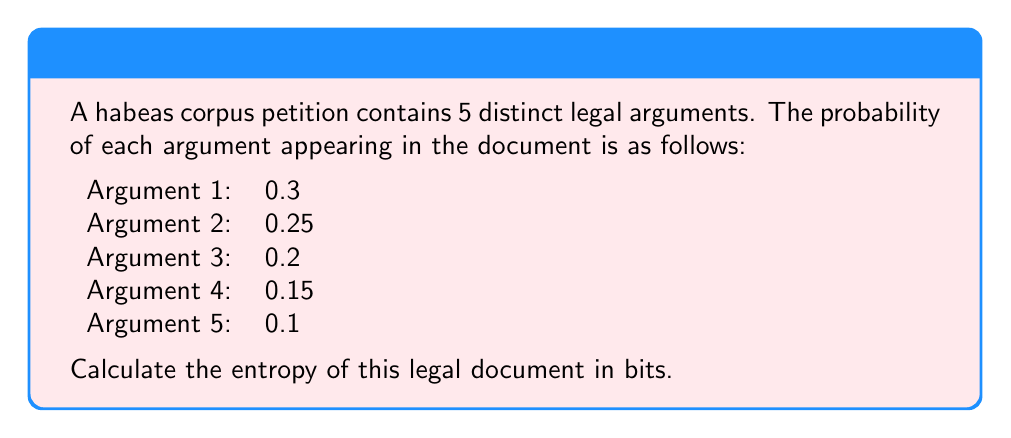What is the answer to this math problem? To calculate the entropy of the legal document, we need to use Shannon's entropy formula:

$$ H = -\sum_{i=1}^{n} p_i \log_2(p_i) $$

Where:
- $H$ is the entropy in bits
- $p_i$ is the probability of each argument
- $n$ is the number of distinct arguments

Let's calculate the entropy for each argument:

1. $-0.3 \log_2(0.3) = 0.521$
2. $-0.25 \log_2(0.25) = 0.5$
3. $-0.2 \log_2(0.2) = 0.464$
4. $-0.15 \log_2(0.15) = 0.411$
5. $-0.1 \log_2(0.1) = 0.332$

Now, we sum these values:

$$ H = 0.521 + 0.5 + 0.464 + 0.411 + 0.332 = 2.228 $$

Therefore, the entropy of the legal document is approximately 2.228 bits.
Answer: 2.228 bits 